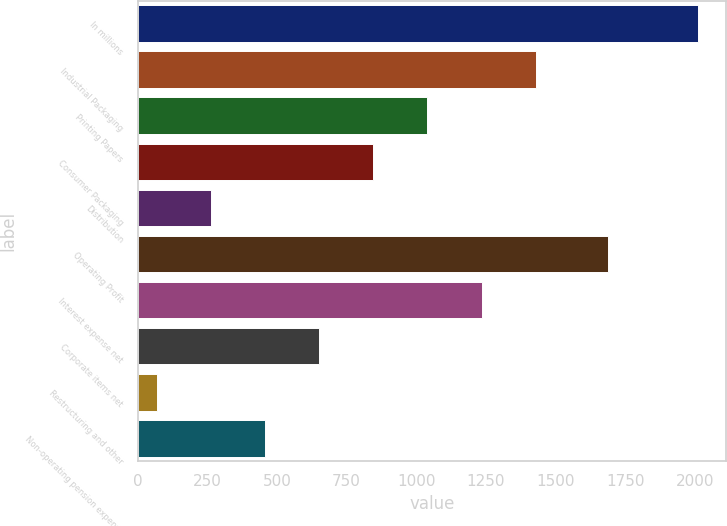Convert chart. <chart><loc_0><loc_0><loc_500><loc_500><bar_chart><fcel>In millions<fcel>Industrial Packaging<fcel>Printing Papers<fcel>Consumer Packaging<fcel>Distribution<fcel>Operating Profit<fcel>Interest expense net<fcel>Corporate items net<fcel>Restructuring and other<fcel>Non-operating pension expense<nl><fcel>2010<fcel>1428<fcel>1040<fcel>846<fcel>264<fcel>1686<fcel>1234<fcel>652<fcel>70<fcel>458<nl></chart> 